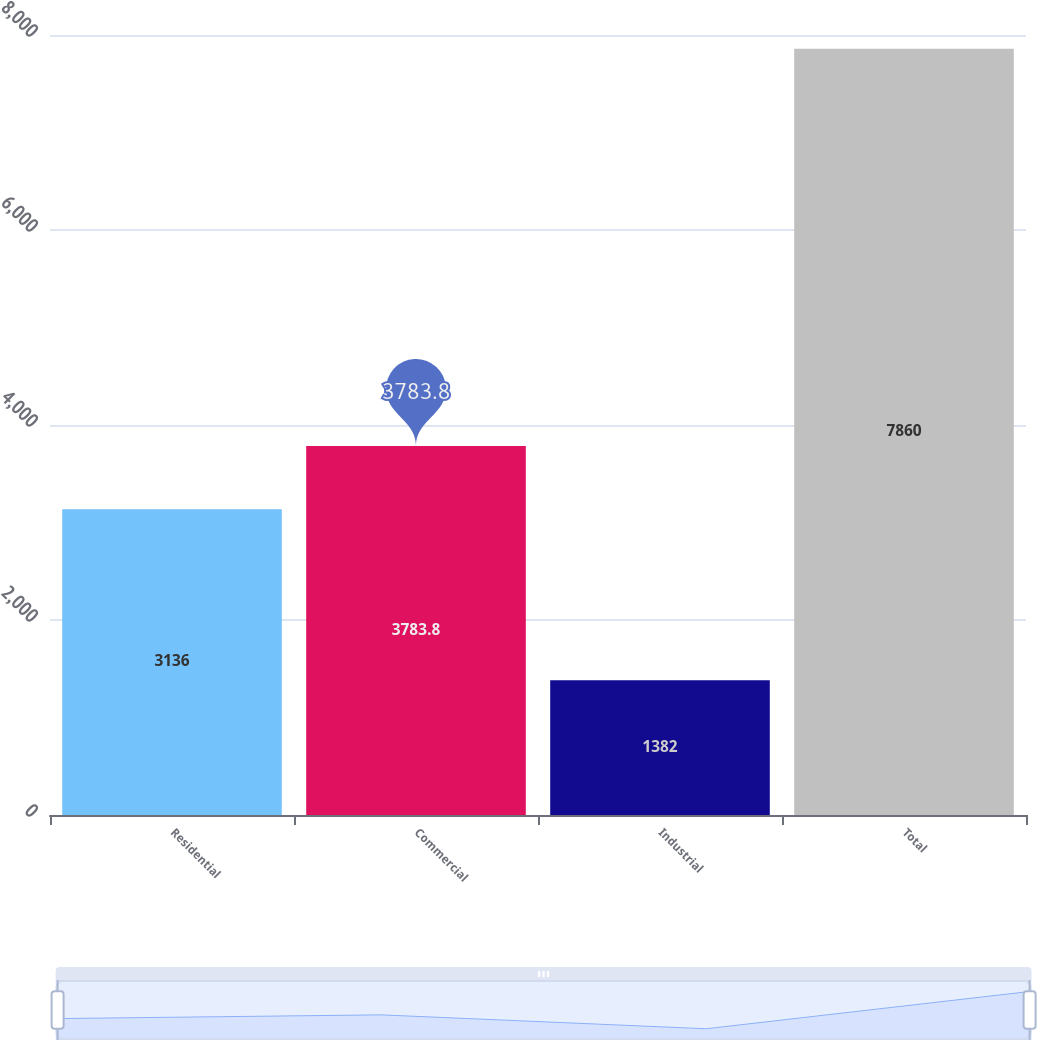Convert chart. <chart><loc_0><loc_0><loc_500><loc_500><bar_chart><fcel>Residential<fcel>Commercial<fcel>Industrial<fcel>Total<nl><fcel>3136<fcel>3783.8<fcel>1382<fcel>7860<nl></chart> 